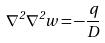Convert formula to latex. <formula><loc_0><loc_0><loc_500><loc_500>\nabla ^ { 2 } \nabla ^ { 2 } w = - \frac { q } { D }</formula> 